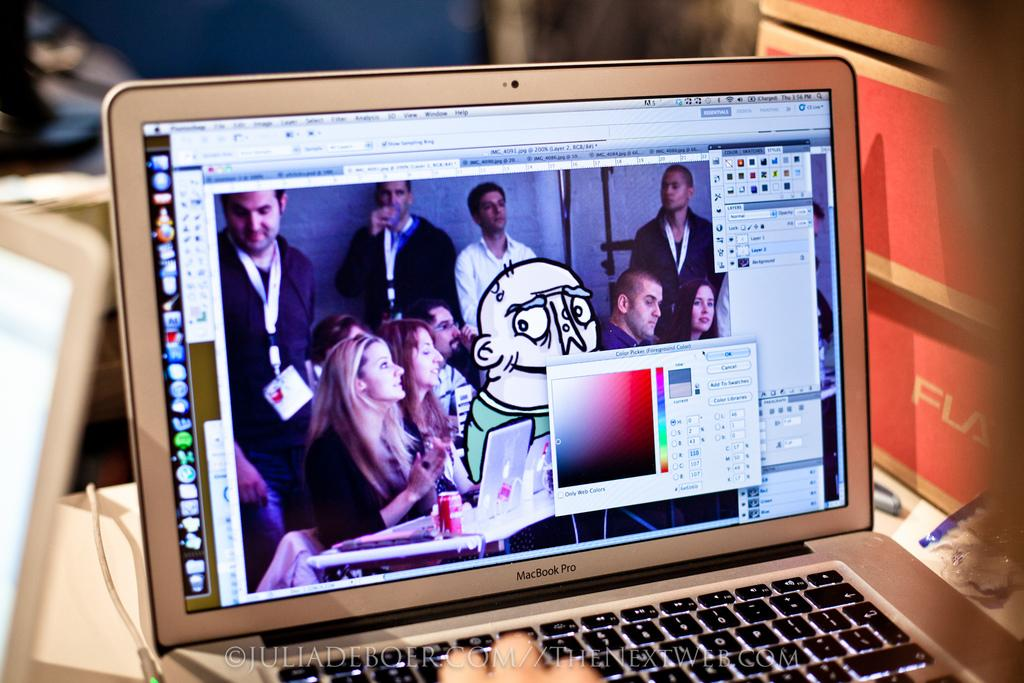<image>
Write a terse but informative summary of the picture. A person is using a laptop with a photo editing program open to the color picker. 